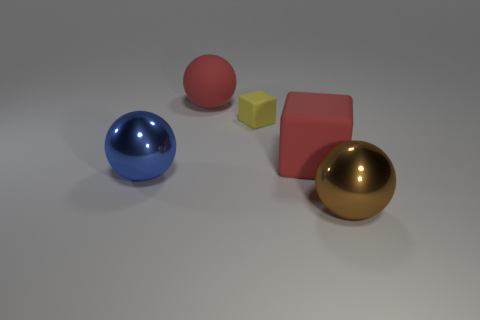Are there any other things that are the same size as the yellow matte object?
Make the answer very short. No. What color is the sphere that is left of the big red rubber block and in front of the small yellow rubber thing?
Provide a short and direct response. Blue. Are the big red cube and the large blue object made of the same material?
Offer a terse response. No. What number of small things are either brown spheres or yellow shiny objects?
Your answer should be very brief. 0. Is there any other thing that is the same shape as the yellow rubber thing?
Keep it short and to the point. Yes. What color is the big object that is made of the same material as the large cube?
Provide a short and direct response. Red. What color is the large shiny thing behind the brown ball?
Give a very brief answer. Blue. What number of objects are the same color as the tiny cube?
Offer a very short reply. 0. Are there fewer rubber blocks that are to the right of the small rubber cube than big red things behind the red ball?
Provide a short and direct response. No. There is a brown metallic sphere; what number of tiny yellow things are in front of it?
Offer a terse response. 0. 